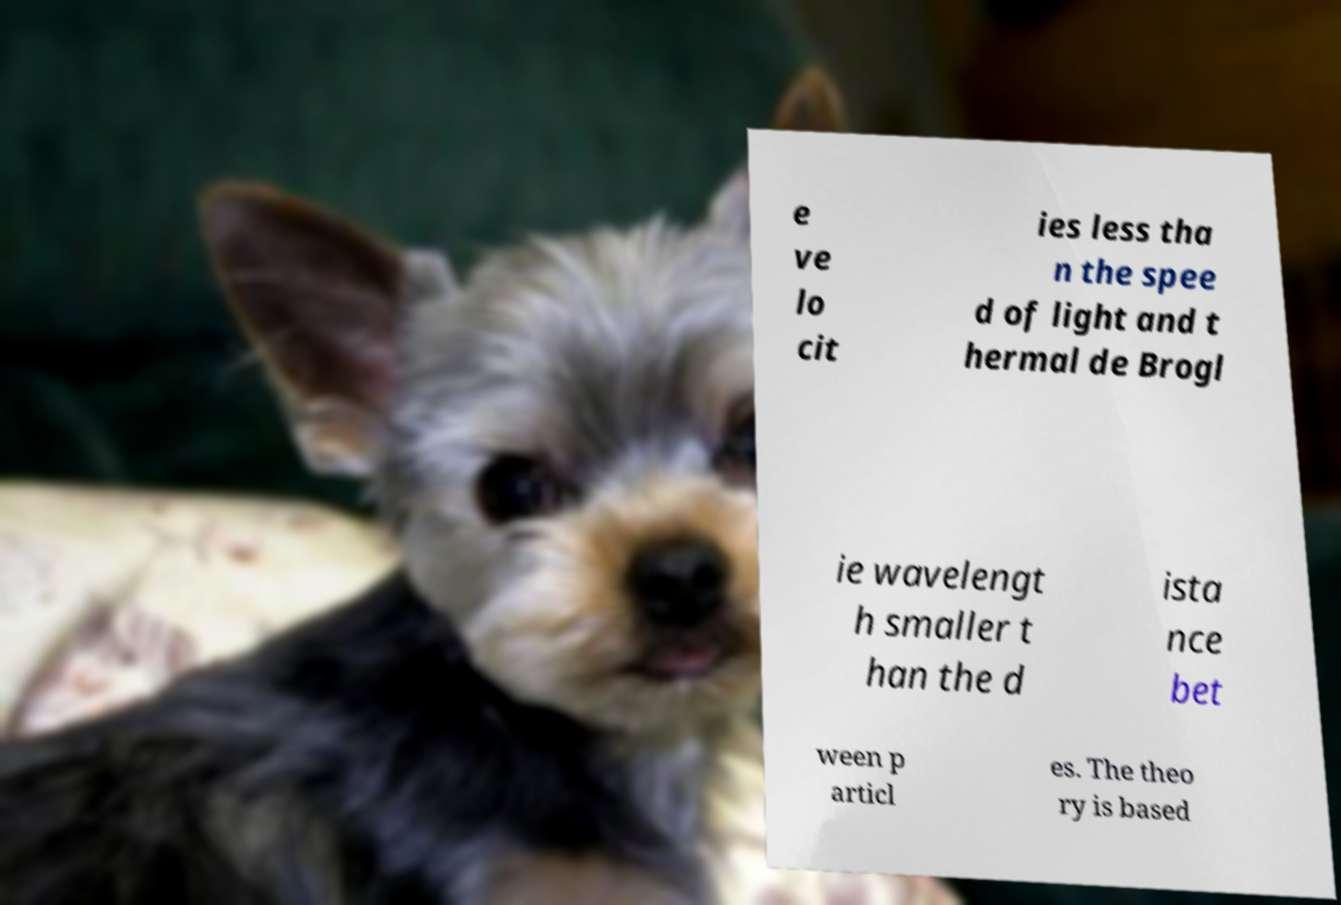Could you extract and type out the text from this image? e ve lo cit ies less tha n the spee d of light and t hermal de Brogl ie wavelengt h smaller t han the d ista nce bet ween p articl es. The theo ry is based 